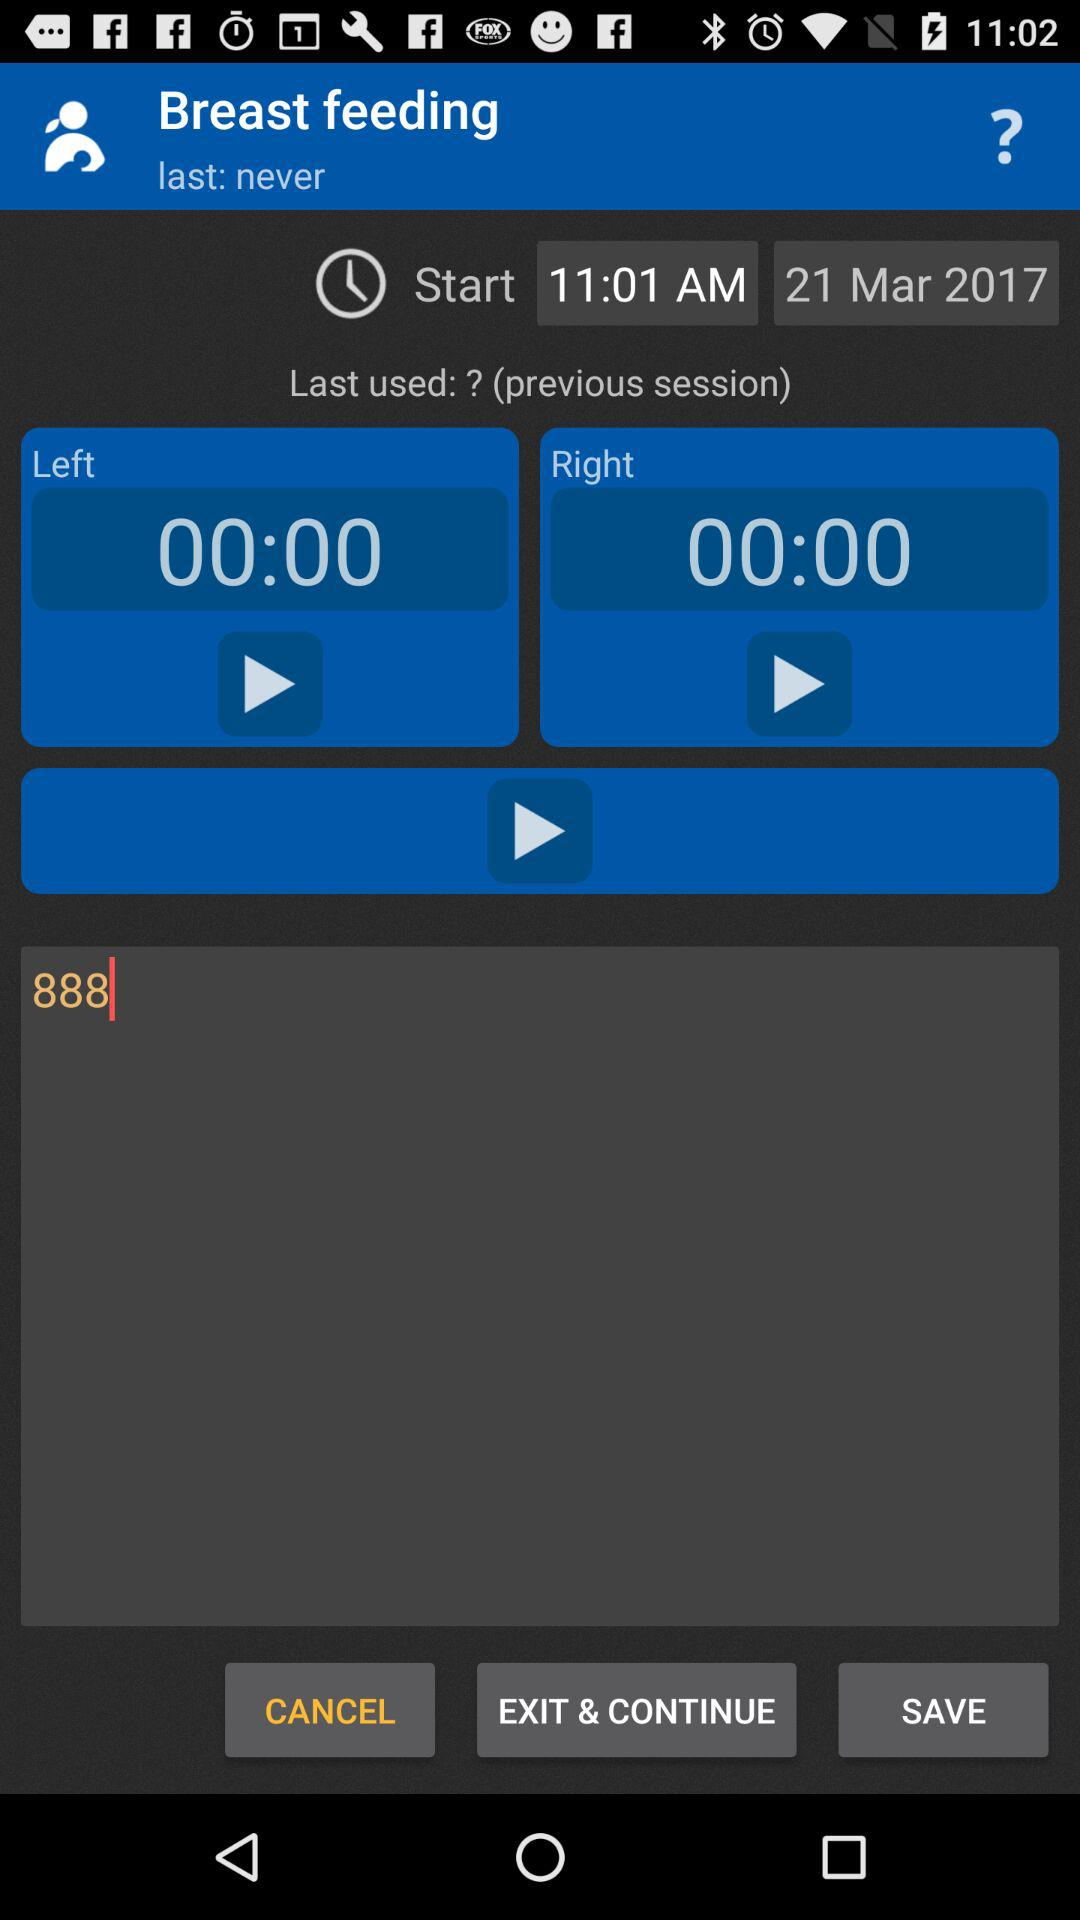What is the starting time for breast feeding? The starting time for breast feeding is 11:01 AM. 